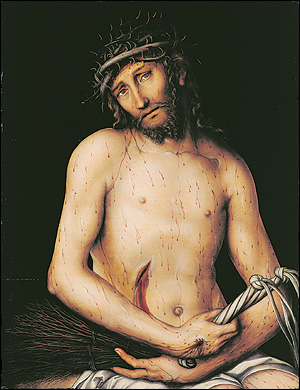What does the use of lighting tell us about the focal points in this artwork? The artist strategically uses light to focus the viewer's attention on the face and upper body of Christ, particularly highlighting his expression and the crown of thorns. The choice of lighting casts shadows across the body, which emphasizes the contours of his physique and the wounds, enhancing the dramatic impact of the piece. This technique not only draws attention to the central figure but also symbolically illuminates the themes of suffering and humanity central to the narrative. 